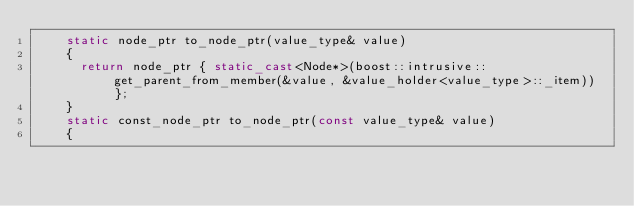<code> <loc_0><loc_0><loc_500><loc_500><_C++_>		static node_ptr to_node_ptr(value_type& value)
		{
			return node_ptr { static_cast<Node*>(boost::intrusive::get_parent_from_member(&value, &value_holder<value_type>::_item)) };
		}
		static const_node_ptr to_node_ptr(const value_type& value)
		{</code> 